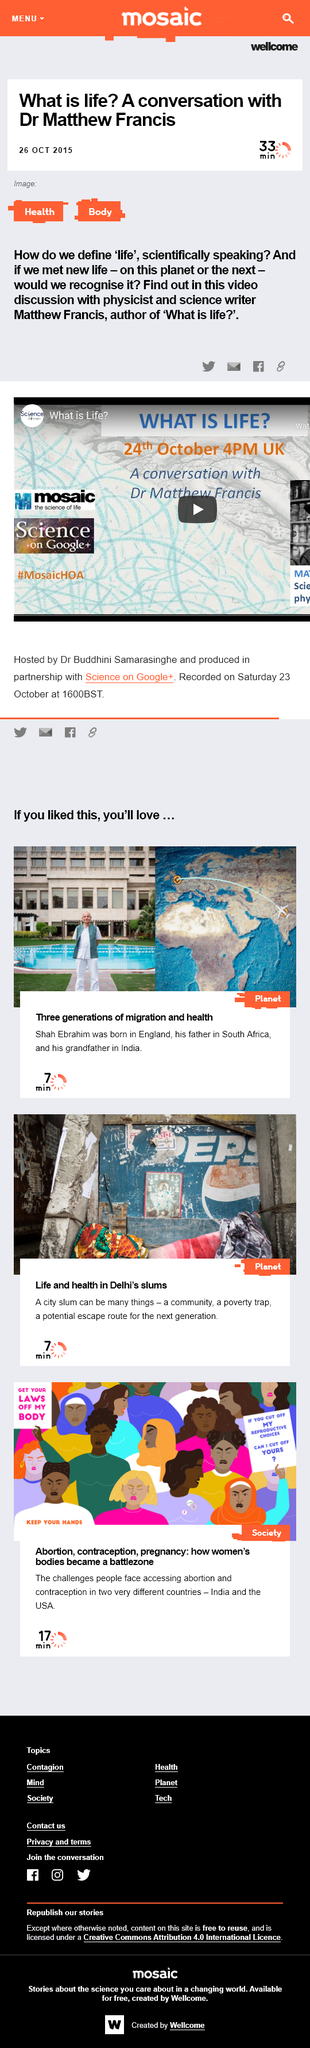List a handful of essential elements in this visual. It is established that Matthew Francis is the author of 'What is life?' The article on my conversation with Matthew Francis was published on October 26, 2015. Matthew Francis is a physicist and science writer who is known for his expertise in the field of physics. 